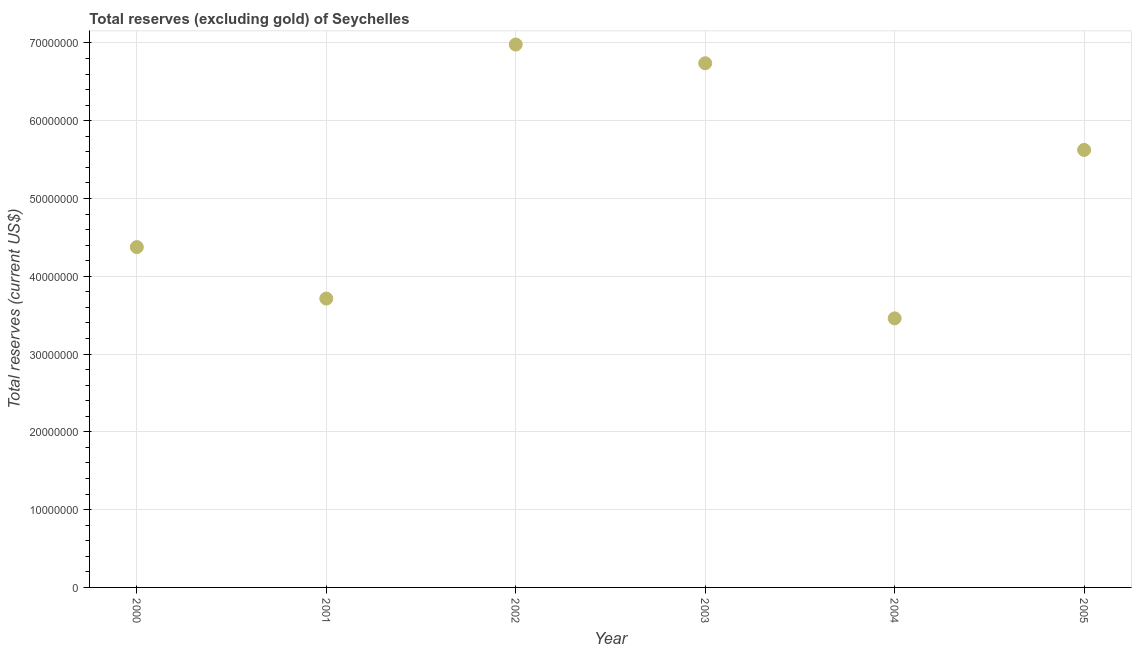What is the total reserves (excluding gold) in 2000?
Provide a short and direct response. 4.38e+07. Across all years, what is the maximum total reserves (excluding gold)?
Your answer should be compact. 6.98e+07. Across all years, what is the minimum total reserves (excluding gold)?
Provide a succinct answer. 3.46e+07. What is the sum of the total reserves (excluding gold)?
Give a very brief answer. 3.09e+08. What is the difference between the total reserves (excluding gold) in 2002 and 2003?
Provide a succinct answer. 2.41e+06. What is the average total reserves (excluding gold) per year?
Your answer should be very brief. 5.15e+07. What is the median total reserves (excluding gold)?
Offer a terse response. 5.00e+07. In how many years, is the total reserves (excluding gold) greater than 32000000 US$?
Your answer should be very brief. 6. What is the ratio of the total reserves (excluding gold) in 2001 to that in 2003?
Provide a short and direct response. 0.55. Is the difference between the total reserves (excluding gold) in 2003 and 2004 greater than the difference between any two years?
Your answer should be compact. No. What is the difference between the highest and the second highest total reserves (excluding gold)?
Provide a succinct answer. 2.41e+06. What is the difference between the highest and the lowest total reserves (excluding gold)?
Provide a succinct answer. 3.52e+07. In how many years, is the total reserves (excluding gold) greater than the average total reserves (excluding gold) taken over all years?
Your answer should be very brief. 3. Does the total reserves (excluding gold) monotonically increase over the years?
Provide a short and direct response. No. How many years are there in the graph?
Give a very brief answer. 6. What is the difference between two consecutive major ticks on the Y-axis?
Offer a very short reply. 1.00e+07. Are the values on the major ticks of Y-axis written in scientific E-notation?
Give a very brief answer. No. What is the title of the graph?
Make the answer very short. Total reserves (excluding gold) of Seychelles. What is the label or title of the X-axis?
Provide a succinct answer. Year. What is the label or title of the Y-axis?
Provide a succinct answer. Total reserves (current US$). What is the Total reserves (current US$) in 2000?
Your response must be concise. 4.38e+07. What is the Total reserves (current US$) in 2001?
Keep it short and to the point. 3.71e+07. What is the Total reserves (current US$) in 2002?
Your response must be concise. 6.98e+07. What is the Total reserves (current US$) in 2003?
Provide a short and direct response. 6.74e+07. What is the Total reserves (current US$) in 2004?
Keep it short and to the point. 3.46e+07. What is the Total reserves (current US$) in 2005?
Offer a very short reply. 5.62e+07. What is the difference between the Total reserves (current US$) in 2000 and 2001?
Give a very brief answer. 6.62e+06. What is the difference between the Total reserves (current US$) in 2000 and 2002?
Your response must be concise. -2.60e+07. What is the difference between the Total reserves (current US$) in 2000 and 2003?
Offer a terse response. -2.36e+07. What is the difference between the Total reserves (current US$) in 2000 and 2004?
Offer a terse response. 9.16e+06. What is the difference between the Total reserves (current US$) in 2000 and 2005?
Your response must be concise. -1.25e+07. What is the difference between the Total reserves (current US$) in 2001 and 2002?
Offer a terse response. -3.27e+07. What is the difference between the Total reserves (current US$) in 2001 and 2003?
Offer a very short reply. -3.03e+07. What is the difference between the Total reserves (current US$) in 2001 and 2004?
Keep it short and to the point. 2.54e+06. What is the difference between the Total reserves (current US$) in 2001 and 2005?
Provide a succinct answer. -1.91e+07. What is the difference between the Total reserves (current US$) in 2002 and 2003?
Give a very brief answer. 2.41e+06. What is the difference between the Total reserves (current US$) in 2002 and 2004?
Give a very brief answer. 3.52e+07. What is the difference between the Total reserves (current US$) in 2002 and 2005?
Keep it short and to the point. 1.36e+07. What is the difference between the Total reserves (current US$) in 2003 and 2004?
Offer a very short reply. 3.28e+07. What is the difference between the Total reserves (current US$) in 2003 and 2005?
Make the answer very short. 1.11e+07. What is the difference between the Total reserves (current US$) in 2004 and 2005?
Ensure brevity in your answer.  -2.17e+07. What is the ratio of the Total reserves (current US$) in 2000 to that in 2001?
Your response must be concise. 1.18. What is the ratio of the Total reserves (current US$) in 2000 to that in 2002?
Give a very brief answer. 0.63. What is the ratio of the Total reserves (current US$) in 2000 to that in 2003?
Give a very brief answer. 0.65. What is the ratio of the Total reserves (current US$) in 2000 to that in 2004?
Offer a very short reply. 1.26. What is the ratio of the Total reserves (current US$) in 2000 to that in 2005?
Your answer should be very brief. 0.78. What is the ratio of the Total reserves (current US$) in 2001 to that in 2002?
Your answer should be very brief. 0.53. What is the ratio of the Total reserves (current US$) in 2001 to that in 2003?
Offer a very short reply. 0.55. What is the ratio of the Total reserves (current US$) in 2001 to that in 2004?
Give a very brief answer. 1.07. What is the ratio of the Total reserves (current US$) in 2001 to that in 2005?
Make the answer very short. 0.66. What is the ratio of the Total reserves (current US$) in 2002 to that in 2003?
Your answer should be very brief. 1.04. What is the ratio of the Total reserves (current US$) in 2002 to that in 2004?
Your answer should be compact. 2.02. What is the ratio of the Total reserves (current US$) in 2002 to that in 2005?
Provide a short and direct response. 1.24. What is the ratio of the Total reserves (current US$) in 2003 to that in 2004?
Make the answer very short. 1.95. What is the ratio of the Total reserves (current US$) in 2003 to that in 2005?
Your answer should be compact. 1.2. What is the ratio of the Total reserves (current US$) in 2004 to that in 2005?
Offer a very short reply. 0.61. 